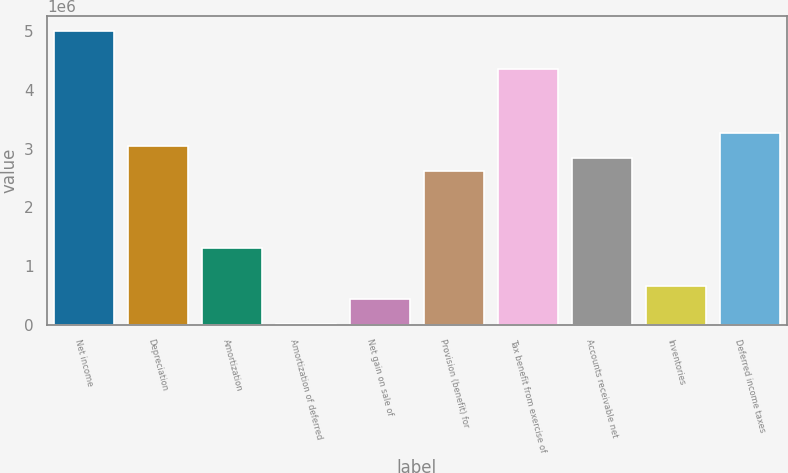Convert chart. <chart><loc_0><loc_0><loc_500><loc_500><bar_chart><fcel>Net income<fcel>Depreciation<fcel>Amortization<fcel>Amortization of deferred<fcel>Net gain on sale of<fcel>Provision (benefit) for<fcel>Tax benefit from exercise of<fcel>Accounts receivable net<fcel>Inventories<fcel>Deferred income taxes<nl><fcel>5.01311e+06<fcel>3.05293e+06<fcel>1.31055e+06<fcel>3767<fcel>439362<fcel>2.61734e+06<fcel>4.35972e+06<fcel>2.83513e+06<fcel>657159<fcel>3.27073e+06<nl></chart> 